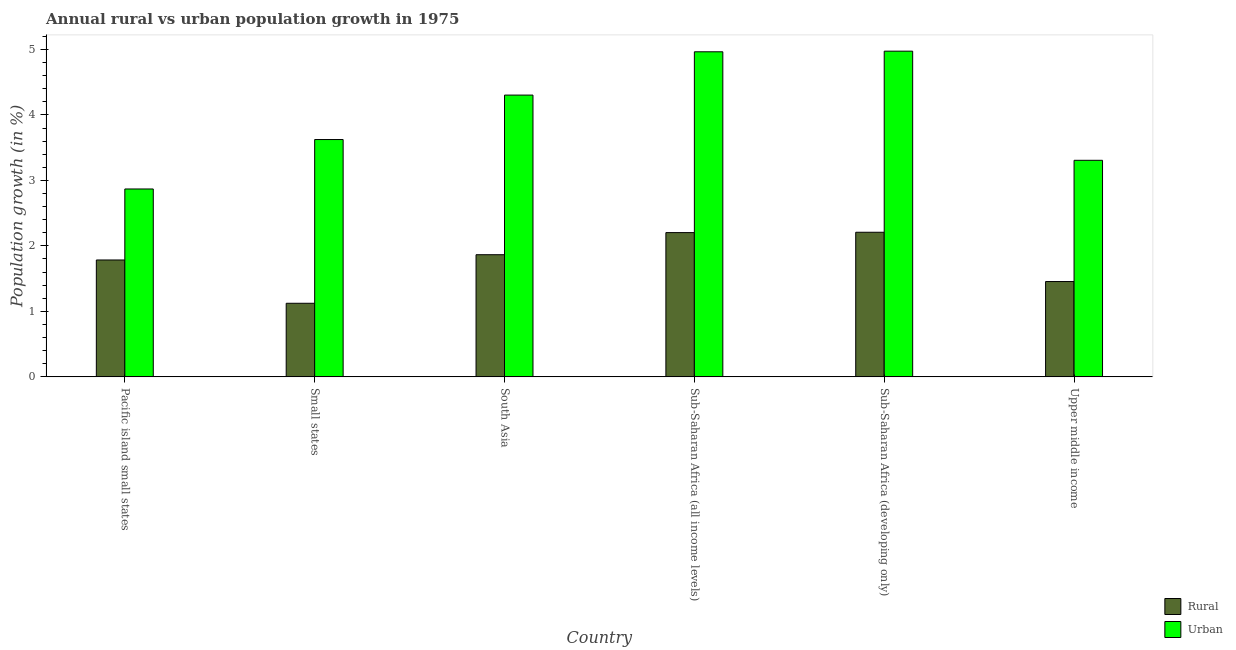How many different coloured bars are there?
Ensure brevity in your answer.  2. How many groups of bars are there?
Keep it short and to the point. 6. Are the number of bars per tick equal to the number of legend labels?
Provide a short and direct response. Yes. How many bars are there on the 1st tick from the left?
Provide a succinct answer. 2. How many bars are there on the 6th tick from the right?
Provide a succinct answer. 2. What is the label of the 6th group of bars from the left?
Keep it short and to the point. Upper middle income. In how many cases, is the number of bars for a given country not equal to the number of legend labels?
Offer a very short reply. 0. What is the rural population growth in Upper middle income?
Offer a very short reply. 1.46. Across all countries, what is the maximum urban population growth?
Your answer should be compact. 4.97. Across all countries, what is the minimum rural population growth?
Your answer should be compact. 1.12. In which country was the rural population growth maximum?
Ensure brevity in your answer.  Sub-Saharan Africa (developing only). In which country was the urban population growth minimum?
Provide a short and direct response. Pacific island small states. What is the total urban population growth in the graph?
Keep it short and to the point. 24.04. What is the difference between the urban population growth in Small states and that in Upper middle income?
Ensure brevity in your answer.  0.32. What is the difference between the urban population growth in Sub-Saharan Africa (all income levels) and the rural population growth in Upper middle income?
Provide a succinct answer. 3.51. What is the average urban population growth per country?
Your answer should be very brief. 4.01. What is the difference between the urban population growth and rural population growth in Small states?
Keep it short and to the point. 2.5. In how many countries, is the rural population growth greater than 3.4 %?
Ensure brevity in your answer.  0. What is the ratio of the rural population growth in South Asia to that in Sub-Saharan Africa (developing only)?
Offer a terse response. 0.84. Is the rural population growth in Small states less than that in South Asia?
Keep it short and to the point. Yes. What is the difference between the highest and the second highest urban population growth?
Make the answer very short. 0.01. What is the difference between the highest and the lowest rural population growth?
Ensure brevity in your answer.  1.08. Is the sum of the urban population growth in Small states and Upper middle income greater than the maximum rural population growth across all countries?
Make the answer very short. Yes. What does the 2nd bar from the left in Upper middle income represents?
Offer a terse response. Urban . What does the 2nd bar from the right in Sub-Saharan Africa (developing only) represents?
Keep it short and to the point. Rural. Are all the bars in the graph horizontal?
Keep it short and to the point. No. What is the difference between two consecutive major ticks on the Y-axis?
Provide a short and direct response. 1. Does the graph contain any zero values?
Provide a succinct answer. No. How many legend labels are there?
Provide a succinct answer. 2. How are the legend labels stacked?
Your answer should be very brief. Vertical. What is the title of the graph?
Provide a succinct answer. Annual rural vs urban population growth in 1975. What is the label or title of the Y-axis?
Offer a very short reply. Population growth (in %). What is the Population growth (in %) in Rural in Pacific island small states?
Make the answer very short. 1.79. What is the Population growth (in %) in Urban  in Pacific island small states?
Keep it short and to the point. 2.87. What is the Population growth (in %) in Rural in Small states?
Ensure brevity in your answer.  1.12. What is the Population growth (in %) of Urban  in Small states?
Provide a short and direct response. 3.62. What is the Population growth (in %) of Rural in South Asia?
Offer a terse response. 1.87. What is the Population growth (in %) in Urban  in South Asia?
Ensure brevity in your answer.  4.3. What is the Population growth (in %) in Rural in Sub-Saharan Africa (all income levels)?
Offer a terse response. 2.2. What is the Population growth (in %) in Urban  in Sub-Saharan Africa (all income levels)?
Your answer should be compact. 4.96. What is the Population growth (in %) of Rural in Sub-Saharan Africa (developing only)?
Provide a short and direct response. 2.21. What is the Population growth (in %) in Urban  in Sub-Saharan Africa (developing only)?
Offer a very short reply. 4.97. What is the Population growth (in %) in Rural in Upper middle income?
Ensure brevity in your answer.  1.46. What is the Population growth (in %) in Urban  in Upper middle income?
Keep it short and to the point. 3.31. Across all countries, what is the maximum Population growth (in %) in Rural?
Make the answer very short. 2.21. Across all countries, what is the maximum Population growth (in %) of Urban ?
Offer a terse response. 4.97. Across all countries, what is the minimum Population growth (in %) of Rural?
Your response must be concise. 1.12. Across all countries, what is the minimum Population growth (in %) in Urban ?
Offer a very short reply. 2.87. What is the total Population growth (in %) of Rural in the graph?
Ensure brevity in your answer.  10.64. What is the total Population growth (in %) in Urban  in the graph?
Ensure brevity in your answer.  24.04. What is the difference between the Population growth (in %) in Rural in Pacific island small states and that in Small states?
Provide a succinct answer. 0.66. What is the difference between the Population growth (in %) in Urban  in Pacific island small states and that in Small states?
Your answer should be compact. -0.75. What is the difference between the Population growth (in %) of Rural in Pacific island small states and that in South Asia?
Offer a very short reply. -0.08. What is the difference between the Population growth (in %) of Urban  in Pacific island small states and that in South Asia?
Keep it short and to the point. -1.43. What is the difference between the Population growth (in %) of Rural in Pacific island small states and that in Sub-Saharan Africa (all income levels)?
Keep it short and to the point. -0.42. What is the difference between the Population growth (in %) in Urban  in Pacific island small states and that in Sub-Saharan Africa (all income levels)?
Your answer should be compact. -2.09. What is the difference between the Population growth (in %) in Rural in Pacific island small states and that in Sub-Saharan Africa (developing only)?
Provide a succinct answer. -0.42. What is the difference between the Population growth (in %) of Urban  in Pacific island small states and that in Sub-Saharan Africa (developing only)?
Your answer should be very brief. -2.1. What is the difference between the Population growth (in %) of Rural in Pacific island small states and that in Upper middle income?
Offer a very short reply. 0.33. What is the difference between the Population growth (in %) in Urban  in Pacific island small states and that in Upper middle income?
Give a very brief answer. -0.44. What is the difference between the Population growth (in %) of Rural in Small states and that in South Asia?
Make the answer very short. -0.74. What is the difference between the Population growth (in %) of Urban  in Small states and that in South Asia?
Offer a very short reply. -0.68. What is the difference between the Population growth (in %) in Rural in Small states and that in Sub-Saharan Africa (all income levels)?
Your answer should be compact. -1.08. What is the difference between the Population growth (in %) in Urban  in Small states and that in Sub-Saharan Africa (all income levels)?
Ensure brevity in your answer.  -1.34. What is the difference between the Population growth (in %) of Rural in Small states and that in Sub-Saharan Africa (developing only)?
Your answer should be very brief. -1.08. What is the difference between the Population growth (in %) of Urban  in Small states and that in Sub-Saharan Africa (developing only)?
Keep it short and to the point. -1.35. What is the difference between the Population growth (in %) of Rural in Small states and that in Upper middle income?
Offer a very short reply. -0.33. What is the difference between the Population growth (in %) in Urban  in Small states and that in Upper middle income?
Keep it short and to the point. 0.32. What is the difference between the Population growth (in %) in Rural in South Asia and that in Sub-Saharan Africa (all income levels)?
Ensure brevity in your answer.  -0.34. What is the difference between the Population growth (in %) in Urban  in South Asia and that in Sub-Saharan Africa (all income levels)?
Make the answer very short. -0.66. What is the difference between the Population growth (in %) of Rural in South Asia and that in Sub-Saharan Africa (developing only)?
Keep it short and to the point. -0.34. What is the difference between the Population growth (in %) in Urban  in South Asia and that in Sub-Saharan Africa (developing only)?
Provide a succinct answer. -0.67. What is the difference between the Population growth (in %) in Rural in South Asia and that in Upper middle income?
Your answer should be very brief. 0.41. What is the difference between the Population growth (in %) in Urban  in South Asia and that in Upper middle income?
Keep it short and to the point. 1. What is the difference between the Population growth (in %) of Rural in Sub-Saharan Africa (all income levels) and that in Sub-Saharan Africa (developing only)?
Keep it short and to the point. -0.01. What is the difference between the Population growth (in %) in Urban  in Sub-Saharan Africa (all income levels) and that in Sub-Saharan Africa (developing only)?
Ensure brevity in your answer.  -0.01. What is the difference between the Population growth (in %) of Rural in Sub-Saharan Africa (all income levels) and that in Upper middle income?
Provide a succinct answer. 0.75. What is the difference between the Population growth (in %) in Urban  in Sub-Saharan Africa (all income levels) and that in Upper middle income?
Make the answer very short. 1.66. What is the difference between the Population growth (in %) of Rural in Sub-Saharan Africa (developing only) and that in Upper middle income?
Provide a short and direct response. 0.75. What is the difference between the Population growth (in %) in Urban  in Sub-Saharan Africa (developing only) and that in Upper middle income?
Your answer should be compact. 1.67. What is the difference between the Population growth (in %) of Rural in Pacific island small states and the Population growth (in %) of Urban  in Small states?
Provide a succinct answer. -1.84. What is the difference between the Population growth (in %) of Rural in Pacific island small states and the Population growth (in %) of Urban  in South Asia?
Ensure brevity in your answer.  -2.52. What is the difference between the Population growth (in %) in Rural in Pacific island small states and the Population growth (in %) in Urban  in Sub-Saharan Africa (all income levels)?
Ensure brevity in your answer.  -3.18. What is the difference between the Population growth (in %) in Rural in Pacific island small states and the Population growth (in %) in Urban  in Sub-Saharan Africa (developing only)?
Offer a very short reply. -3.19. What is the difference between the Population growth (in %) in Rural in Pacific island small states and the Population growth (in %) in Urban  in Upper middle income?
Provide a succinct answer. -1.52. What is the difference between the Population growth (in %) of Rural in Small states and the Population growth (in %) of Urban  in South Asia?
Provide a short and direct response. -3.18. What is the difference between the Population growth (in %) of Rural in Small states and the Population growth (in %) of Urban  in Sub-Saharan Africa (all income levels)?
Offer a terse response. -3.84. What is the difference between the Population growth (in %) in Rural in Small states and the Population growth (in %) in Urban  in Sub-Saharan Africa (developing only)?
Ensure brevity in your answer.  -3.85. What is the difference between the Population growth (in %) of Rural in Small states and the Population growth (in %) of Urban  in Upper middle income?
Keep it short and to the point. -2.18. What is the difference between the Population growth (in %) of Rural in South Asia and the Population growth (in %) of Urban  in Sub-Saharan Africa (all income levels)?
Your answer should be compact. -3.1. What is the difference between the Population growth (in %) in Rural in South Asia and the Population growth (in %) in Urban  in Sub-Saharan Africa (developing only)?
Provide a short and direct response. -3.11. What is the difference between the Population growth (in %) in Rural in South Asia and the Population growth (in %) in Urban  in Upper middle income?
Provide a succinct answer. -1.44. What is the difference between the Population growth (in %) of Rural in Sub-Saharan Africa (all income levels) and the Population growth (in %) of Urban  in Sub-Saharan Africa (developing only)?
Offer a very short reply. -2.77. What is the difference between the Population growth (in %) in Rural in Sub-Saharan Africa (all income levels) and the Population growth (in %) in Urban  in Upper middle income?
Provide a short and direct response. -1.1. What is the difference between the Population growth (in %) in Rural in Sub-Saharan Africa (developing only) and the Population growth (in %) in Urban  in Upper middle income?
Offer a terse response. -1.1. What is the average Population growth (in %) of Rural per country?
Give a very brief answer. 1.77. What is the average Population growth (in %) in Urban  per country?
Your answer should be compact. 4.01. What is the difference between the Population growth (in %) of Rural and Population growth (in %) of Urban  in Pacific island small states?
Ensure brevity in your answer.  -1.08. What is the difference between the Population growth (in %) of Rural and Population growth (in %) of Urban  in Small states?
Give a very brief answer. -2.5. What is the difference between the Population growth (in %) in Rural and Population growth (in %) in Urban  in South Asia?
Your answer should be compact. -2.44. What is the difference between the Population growth (in %) in Rural and Population growth (in %) in Urban  in Sub-Saharan Africa (all income levels)?
Your answer should be very brief. -2.76. What is the difference between the Population growth (in %) in Rural and Population growth (in %) in Urban  in Sub-Saharan Africa (developing only)?
Provide a short and direct response. -2.77. What is the difference between the Population growth (in %) of Rural and Population growth (in %) of Urban  in Upper middle income?
Make the answer very short. -1.85. What is the ratio of the Population growth (in %) of Rural in Pacific island small states to that in Small states?
Provide a succinct answer. 1.59. What is the ratio of the Population growth (in %) in Urban  in Pacific island small states to that in Small states?
Keep it short and to the point. 0.79. What is the ratio of the Population growth (in %) in Rural in Pacific island small states to that in South Asia?
Your answer should be very brief. 0.96. What is the ratio of the Population growth (in %) in Urban  in Pacific island small states to that in South Asia?
Provide a succinct answer. 0.67. What is the ratio of the Population growth (in %) of Rural in Pacific island small states to that in Sub-Saharan Africa (all income levels)?
Your response must be concise. 0.81. What is the ratio of the Population growth (in %) of Urban  in Pacific island small states to that in Sub-Saharan Africa (all income levels)?
Keep it short and to the point. 0.58. What is the ratio of the Population growth (in %) of Rural in Pacific island small states to that in Sub-Saharan Africa (developing only)?
Offer a terse response. 0.81. What is the ratio of the Population growth (in %) in Urban  in Pacific island small states to that in Sub-Saharan Africa (developing only)?
Your response must be concise. 0.58. What is the ratio of the Population growth (in %) in Rural in Pacific island small states to that in Upper middle income?
Offer a terse response. 1.23. What is the ratio of the Population growth (in %) of Urban  in Pacific island small states to that in Upper middle income?
Make the answer very short. 0.87. What is the ratio of the Population growth (in %) of Rural in Small states to that in South Asia?
Make the answer very short. 0.6. What is the ratio of the Population growth (in %) in Urban  in Small states to that in South Asia?
Provide a succinct answer. 0.84. What is the ratio of the Population growth (in %) of Rural in Small states to that in Sub-Saharan Africa (all income levels)?
Keep it short and to the point. 0.51. What is the ratio of the Population growth (in %) in Urban  in Small states to that in Sub-Saharan Africa (all income levels)?
Your answer should be compact. 0.73. What is the ratio of the Population growth (in %) of Rural in Small states to that in Sub-Saharan Africa (developing only)?
Keep it short and to the point. 0.51. What is the ratio of the Population growth (in %) in Urban  in Small states to that in Sub-Saharan Africa (developing only)?
Offer a very short reply. 0.73. What is the ratio of the Population growth (in %) of Rural in Small states to that in Upper middle income?
Provide a short and direct response. 0.77. What is the ratio of the Population growth (in %) in Urban  in Small states to that in Upper middle income?
Your answer should be compact. 1.1. What is the ratio of the Population growth (in %) in Rural in South Asia to that in Sub-Saharan Africa (all income levels)?
Your answer should be very brief. 0.85. What is the ratio of the Population growth (in %) of Urban  in South Asia to that in Sub-Saharan Africa (all income levels)?
Offer a very short reply. 0.87. What is the ratio of the Population growth (in %) of Rural in South Asia to that in Sub-Saharan Africa (developing only)?
Offer a terse response. 0.84. What is the ratio of the Population growth (in %) in Urban  in South Asia to that in Sub-Saharan Africa (developing only)?
Your response must be concise. 0.87. What is the ratio of the Population growth (in %) of Rural in South Asia to that in Upper middle income?
Your answer should be compact. 1.28. What is the ratio of the Population growth (in %) in Urban  in South Asia to that in Upper middle income?
Make the answer very short. 1.3. What is the ratio of the Population growth (in %) of Urban  in Sub-Saharan Africa (all income levels) to that in Sub-Saharan Africa (developing only)?
Make the answer very short. 1. What is the ratio of the Population growth (in %) in Rural in Sub-Saharan Africa (all income levels) to that in Upper middle income?
Offer a terse response. 1.51. What is the ratio of the Population growth (in %) of Urban  in Sub-Saharan Africa (all income levels) to that in Upper middle income?
Provide a succinct answer. 1.5. What is the ratio of the Population growth (in %) in Rural in Sub-Saharan Africa (developing only) to that in Upper middle income?
Make the answer very short. 1.52. What is the ratio of the Population growth (in %) of Urban  in Sub-Saharan Africa (developing only) to that in Upper middle income?
Ensure brevity in your answer.  1.5. What is the difference between the highest and the second highest Population growth (in %) in Rural?
Give a very brief answer. 0.01. What is the difference between the highest and the second highest Population growth (in %) of Urban ?
Provide a short and direct response. 0.01. What is the difference between the highest and the lowest Population growth (in %) in Rural?
Your response must be concise. 1.08. What is the difference between the highest and the lowest Population growth (in %) of Urban ?
Provide a short and direct response. 2.1. 